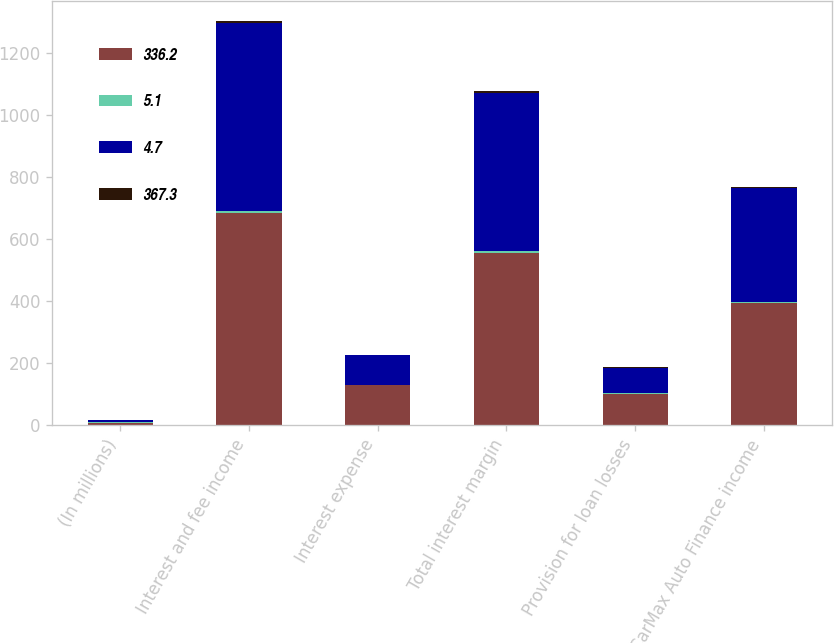<chart> <loc_0><loc_0><loc_500><loc_500><stacked_bar_chart><ecel><fcel>(In millions)<fcel>Interest and fee income<fcel>Interest expense<fcel>Total interest margin<fcel>Provision for loan losses<fcel>CarMax Auto Finance income<nl><fcel>336.2<fcel>7.6<fcel>682.9<fcel>127.7<fcel>555.2<fcel>101.2<fcel>392<nl><fcel>5.1<fcel>1<fcel>7.5<fcel>1.4<fcel>6.1<fcel>1.1<fcel>4.3<nl><fcel>4.7<fcel>7.6<fcel>604.9<fcel>96.6<fcel>508.3<fcel>82.3<fcel>367.3<nl><fcel>367.3<fcel>1<fcel>7.7<fcel>1.2<fcel>6.5<fcel>1<fcel>4.7<nl></chart> 